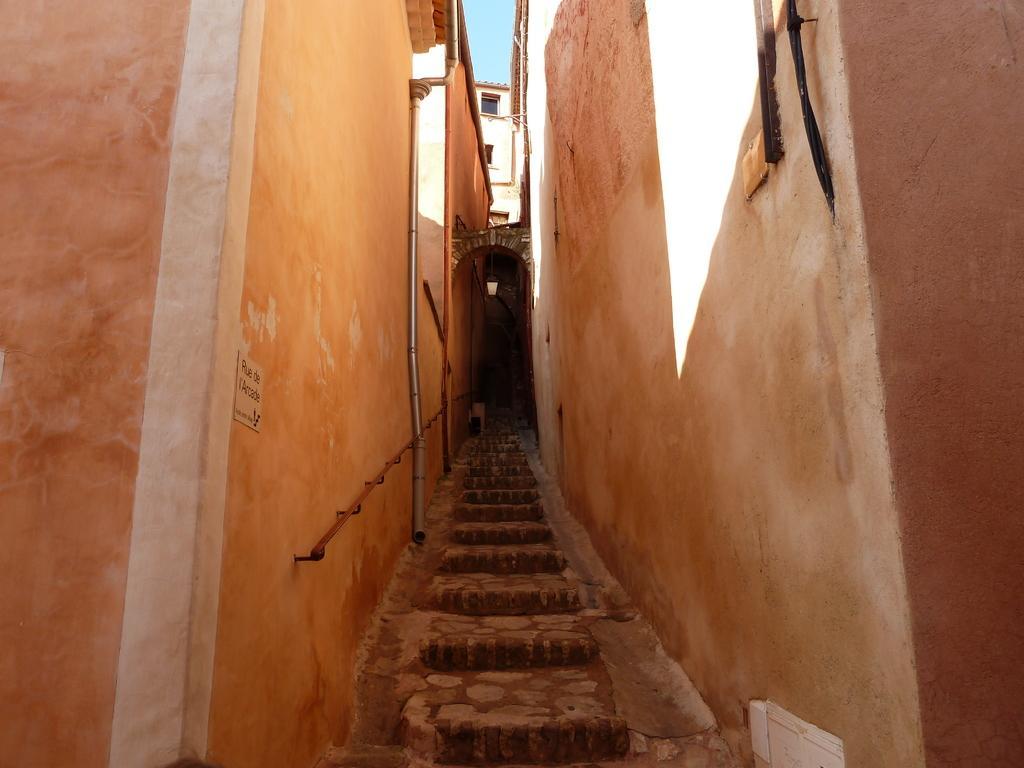Could you give a brief overview of what you see in this image? There are steps. On both sides of the steps, there are walls of the buildings. In the background, there is a building which is having glass windows and there is blue sky. 